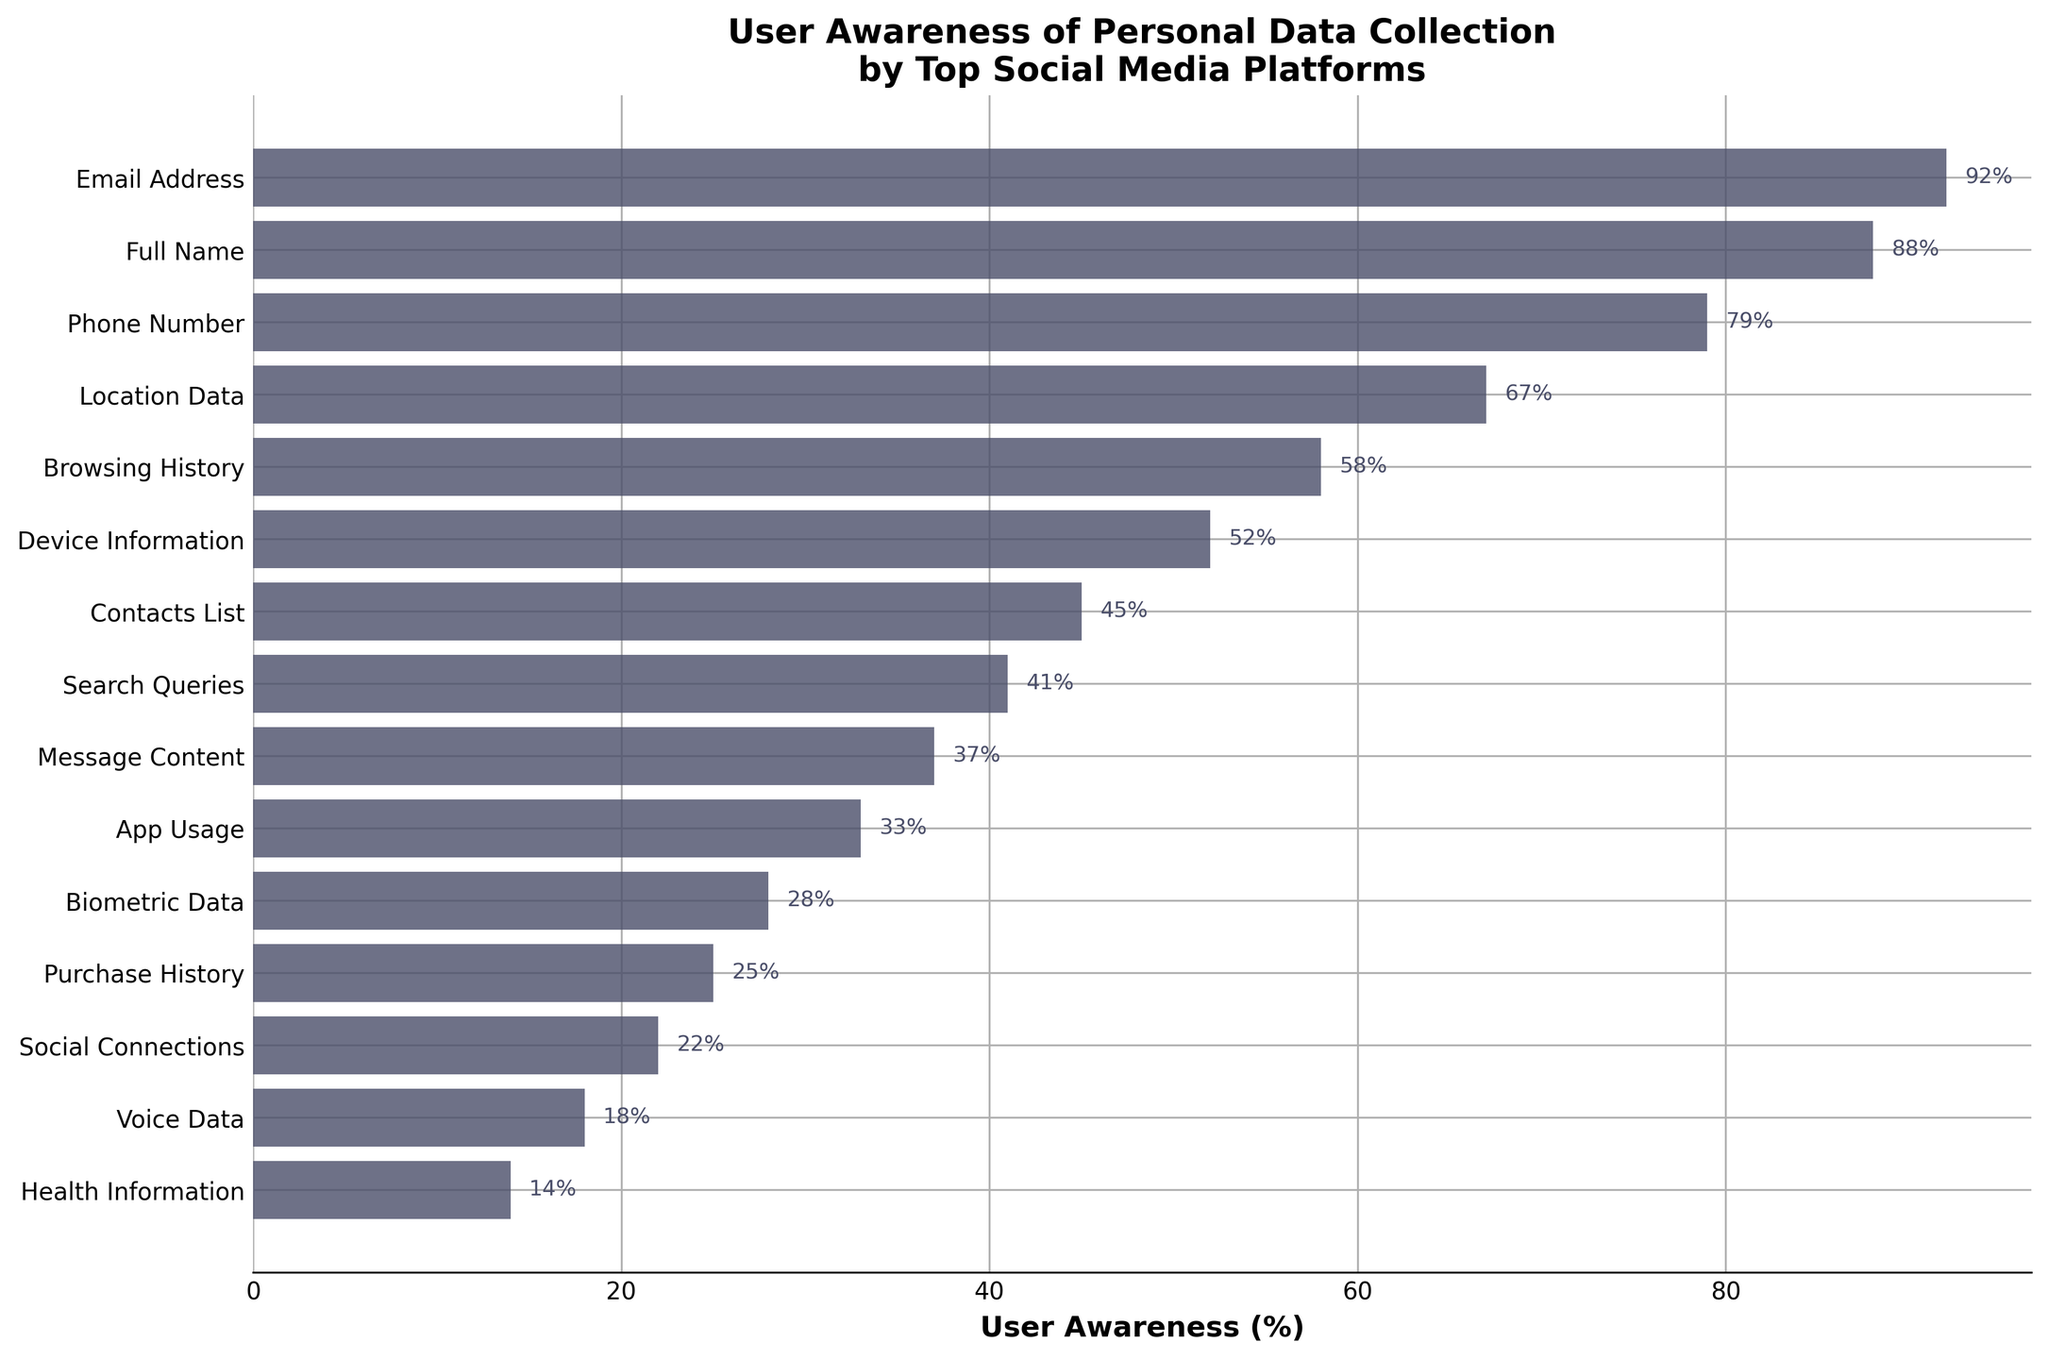Which type of personal data are users most aware is collected by social media platforms? The bar chart shows the ranking of personal data awareness. The longest bar at the top indicates that users are most aware of email address collection, with a user awareness of 92%.
Answer: Email Address What percentage of users are aware that their search queries are collected by social media platforms? Locate the bar labeled "Search Queries" and observe the percentage on the horizontal axis. The text at the end of the bar reads 41%.
Answer: 41% How does user awareness of the collection of browsing history compare to the collection of biometric data? Compare the length of the bars for "Browsing History" and "Biometric Data". The "Browsing History" bar is longer, corresponding to a higher percentage (58%) compared to "Biometric Data" (28%).
Answer: Higher What is the total percentage of user awareness for the top three most recognized data types? Identify the top three bars: "Email Address" (92%), "Full Name" (88%), and "Phone Number" (79%). Sum these percentages: 92 + 88 + 79 = 259.
Answer: 259% Which data type has the lowest user awareness, and what is its value? The shortest bar at the bottom of the chart represents the data type with the lowest awareness. "Health Information" is at the bottom, showing 14%.
Answer: Health Information, 14% Is user awareness higher for app usage data collection or message content data collection? Compare the bars for "App Usage" and "Message Content". "Message Content" has a shorter bar (37%) than "App Usage" (33%), so user awareness is higher for message content.
Answer: Message Content What is the difference in user awareness between device information and social connections? Find the bars for "Device Information" (52%) and "Social Connections" (22%). Calculate the difference: 52 - 22 = 30.
Answer: 30% What is the average user awareness percentage for the collection of contacts list, search queries, and app usage? Find the bars for "Contacts List" (45%), "Search Queries" (41%), and "App Usage" (33%). Calculate the average: (45 + 41 + 33) / 3 ≈ 39.67.
Answer: 39.67% Are users more aware of the collection of location data or purchase history? Compare the bars for "Location Data" and "Purchase History". "Location Data" has a higher percentage (67%) than "Purchase History" (25%).
Answer: Location Data 